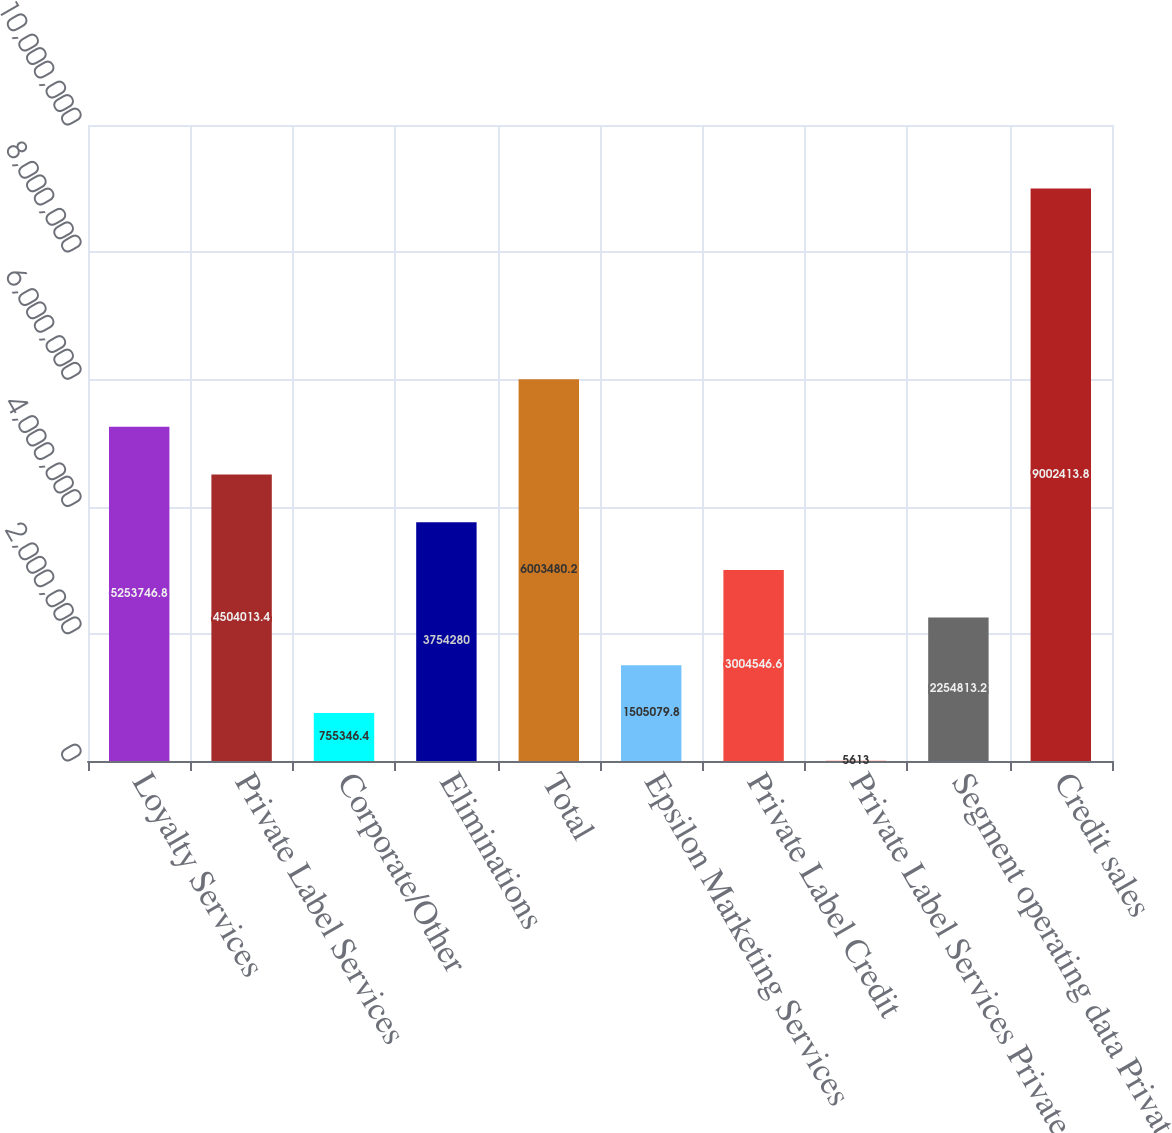Convert chart to OTSL. <chart><loc_0><loc_0><loc_500><loc_500><bar_chart><fcel>Loyalty Services<fcel>Private Label Services<fcel>Corporate/Other<fcel>Eliminations<fcel>Total<fcel>Epsilon Marketing Services<fcel>Private Label Credit<fcel>Private Label Services Private<fcel>Segment operating data Private<fcel>Credit sales<nl><fcel>5.25375e+06<fcel>4.50401e+06<fcel>755346<fcel>3.75428e+06<fcel>6.00348e+06<fcel>1.50508e+06<fcel>3.00455e+06<fcel>5613<fcel>2.25481e+06<fcel>9.00241e+06<nl></chart> 